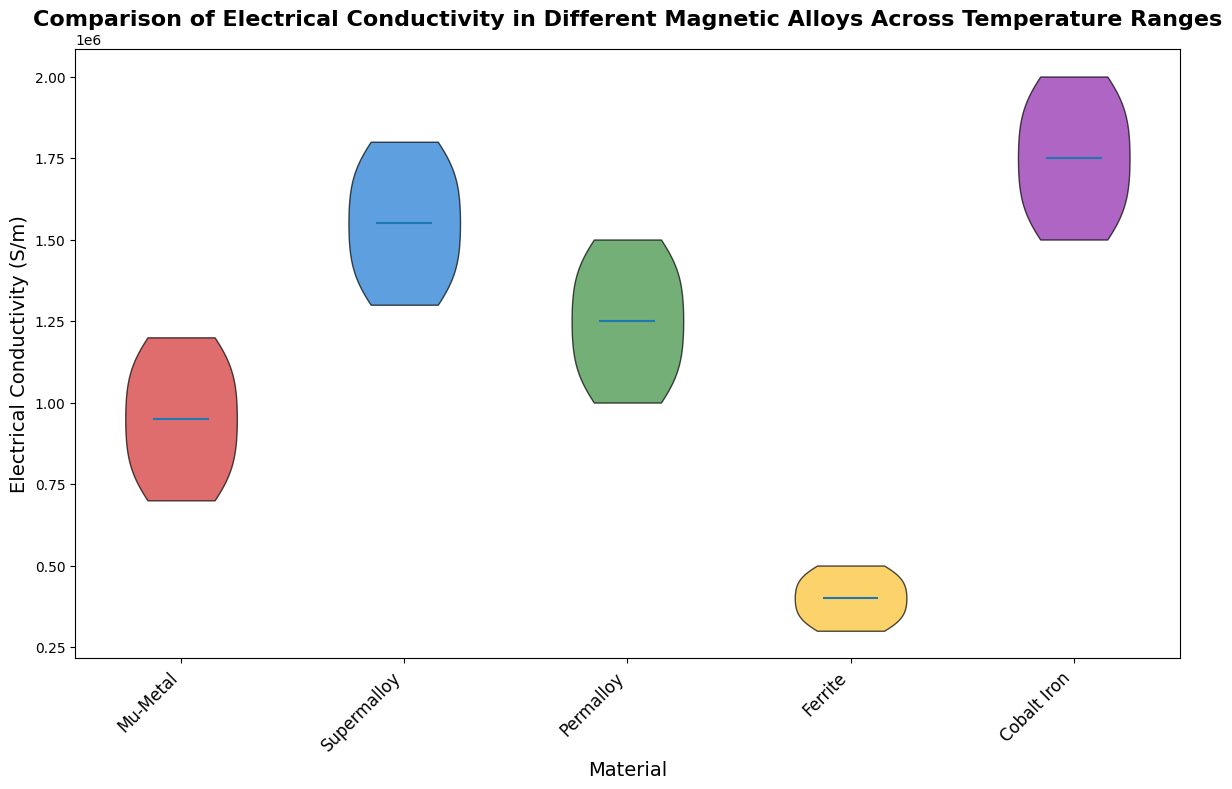Which material shows the highest electrical conductivity across all temperatures? The figure displays multiple violins indicating the distribution of electrical conductivity for different materials across temperatures. The violin representing Cobalt Iron is the highest among all the other materials.
Answer: Cobalt Iron Which material has the lowest median electrical conductivity? The median values are depicted by the horizontal lines in the center of each violin plot. Among all the materials, Ferrite has the lowest median, evident from its median line being the lowest.
Answer: Ferrite Compare the range of electrical conductivity between Mu-Metal and Supermalloy. Which has a wider range? The range in a violin plot can be inferred from the height of each violin. Mu-Metal has a taller violin plot compared to Supermalloy, indicating a wider range of electrical conductivity.
Answer: Mu-Metal Is the median electrical conductivity of Cobalt Iron higher or lower than that of Permalloy? The median values can be compared by looking at the horizontal lines within the violins. The median line of Cobalt Iron is higher than that of Permalloy, indicating a higher median electrical conductivity.
Answer: Higher By visual inspection, which material exhibits the most significant decrease in electrical conductivity with increasing temperature? The slopes of the violins' edges indicate the rate of change. Mu-Metal shows the most substantial decrease, as its violin plot tapers off most significantly as temperature increases.
Answer: Mu-Metal What is the approximate difference in median electrical conductivity between Supermalloy and Mu-Metal? The median values are the horizontal lines inside the violins. Estimating from the plot, Supermalloy's median seems to be around 1700000 S/m and Mu-Metal's around 1050000 S/m. The difference is approximately 650000 S/m.
Answer: 650000 S/m Which material's electrical conductivity has the highest variability across the temperature range? The width of the violins represents the variability. Mu-Metal appears to have the widest violin, indicating the highest variability in electrical conductivity.
Answer: Mu-Metal Which two materials have similar median electrical conductivities? By looking at the horizontal median lines within the violins, Permalloy and Mu-Metal have similar median electrical conductivities as their median lines are very close to each other.
Answer: Permalloy and Mu-Metal 